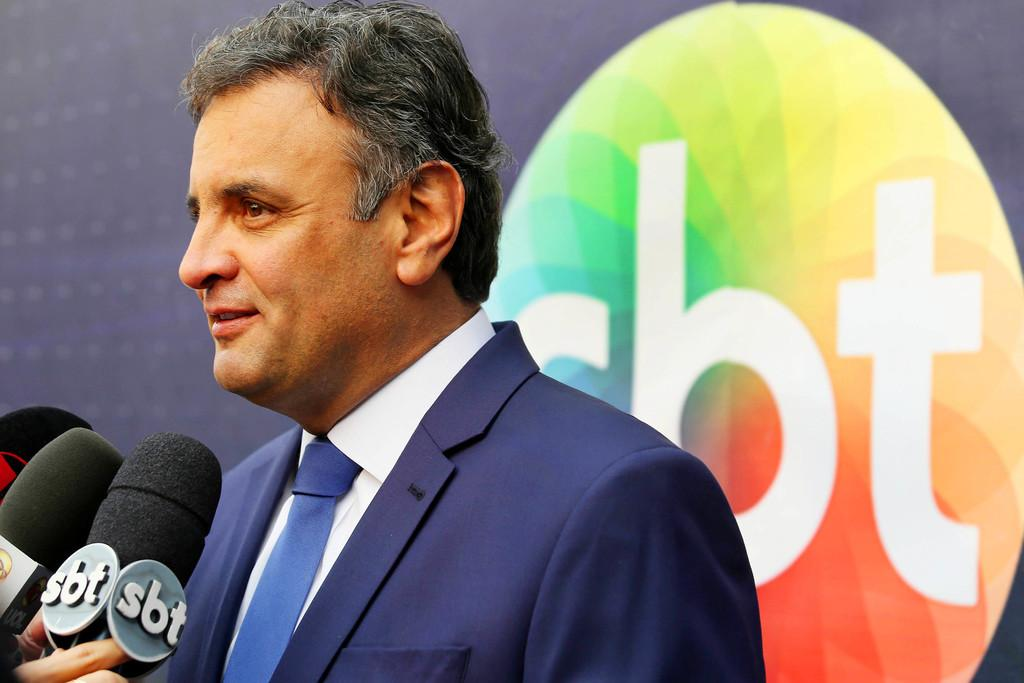What is the man in the image wearing? The man in the image is wearing a blue suit. What can be seen in the bottom left corner of the image? A person's hand holding a mic is visible in the bottom left corner of the corner of the image. What is present in the background of the image? There is a banner in the background of the image. How does the crowd contribute to the pollution in the image? There is no crowd or pollution present in the image; it only features a man in a blue suit, a hand holding a mic, and a banner in the background. 